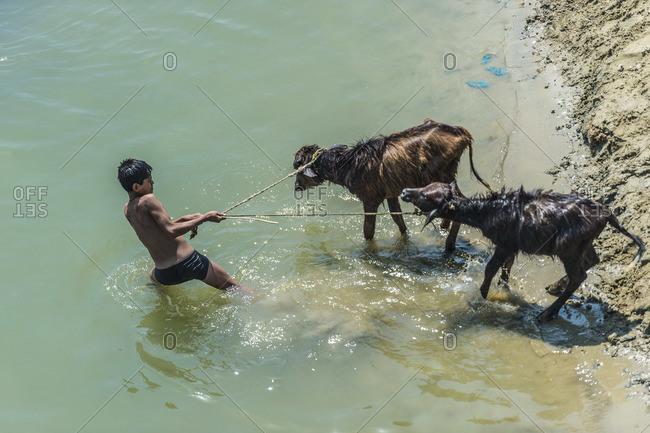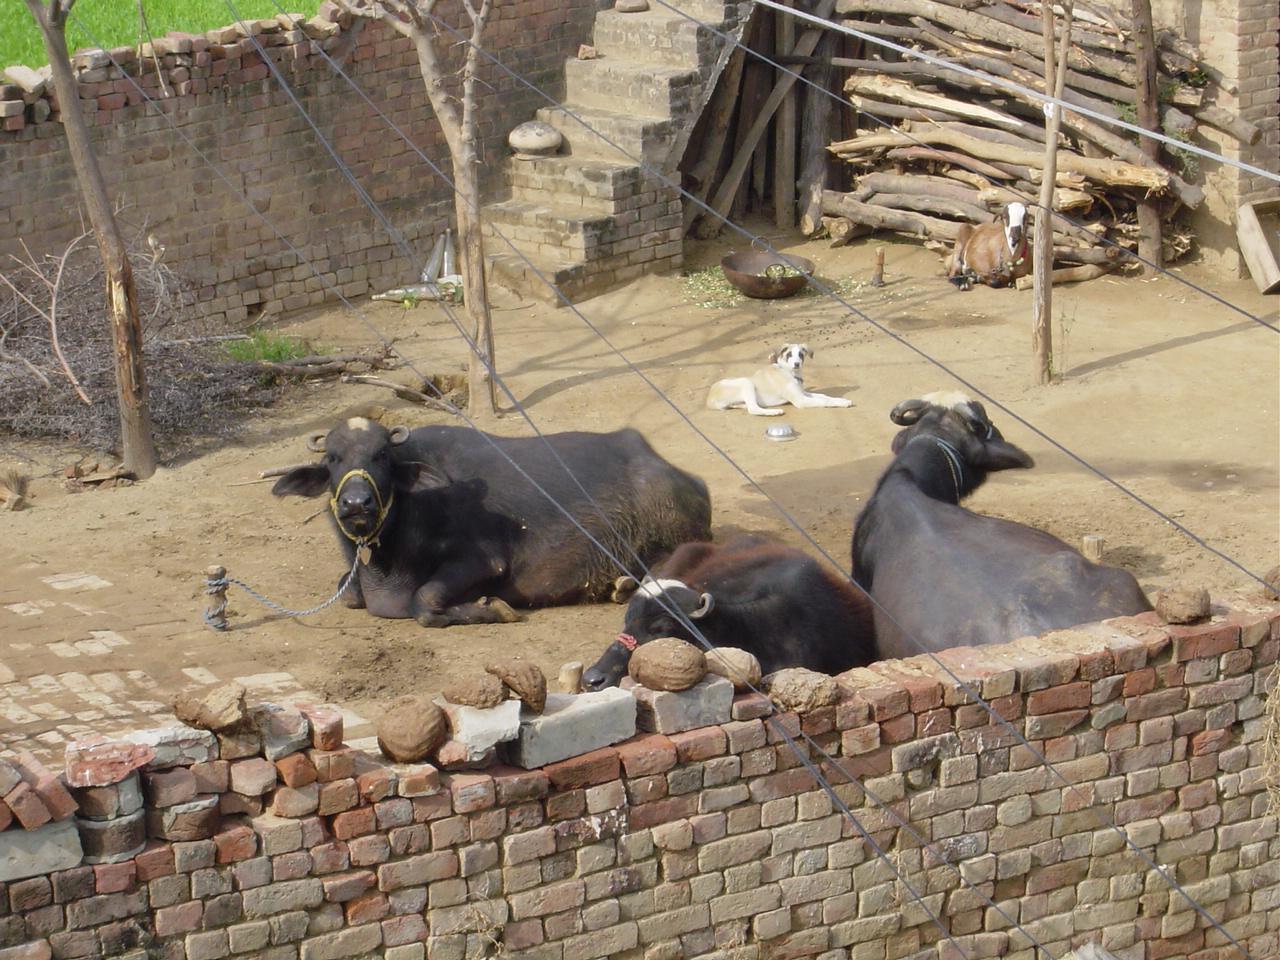The first image is the image on the left, the second image is the image on the right. Assess this claim about the two images: "In one of the images the animals are in the wild.". Correct or not? Answer yes or no. No. The first image is the image on the left, the second image is the image on the right. Analyze the images presented: Is the assertion "There are four animals in total in the image pair." valid? Answer yes or no. No. 